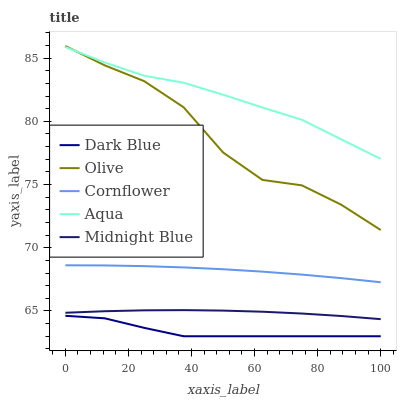Does Dark Blue have the minimum area under the curve?
Answer yes or no. Yes. Does Aqua have the maximum area under the curve?
Answer yes or no. Yes. Does Aqua have the minimum area under the curve?
Answer yes or no. No. Does Dark Blue have the maximum area under the curve?
Answer yes or no. No. Is Cornflower the smoothest?
Answer yes or no. Yes. Is Olive the roughest?
Answer yes or no. Yes. Is Dark Blue the smoothest?
Answer yes or no. No. Is Dark Blue the roughest?
Answer yes or no. No. Does Dark Blue have the lowest value?
Answer yes or no. Yes. Does Aqua have the lowest value?
Answer yes or no. No. Does Olive have the highest value?
Answer yes or no. Yes. Does Aqua have the highest value?
Answer yes or no. No. Is Cornflower less than Olive?
Answer yes or no. Yes. Is Olive greater than Dark Blue?
Answer yes or no. Yes. Does Aqua intersect Olive?
Answer yes or no. Yes. Is Aqua less than Olive?
Answer yes or no. No. Is Aqua greater than Olive?
Answer yes or no. No. Does Cornflower intersect Olive?
Answer yes or no. No. 